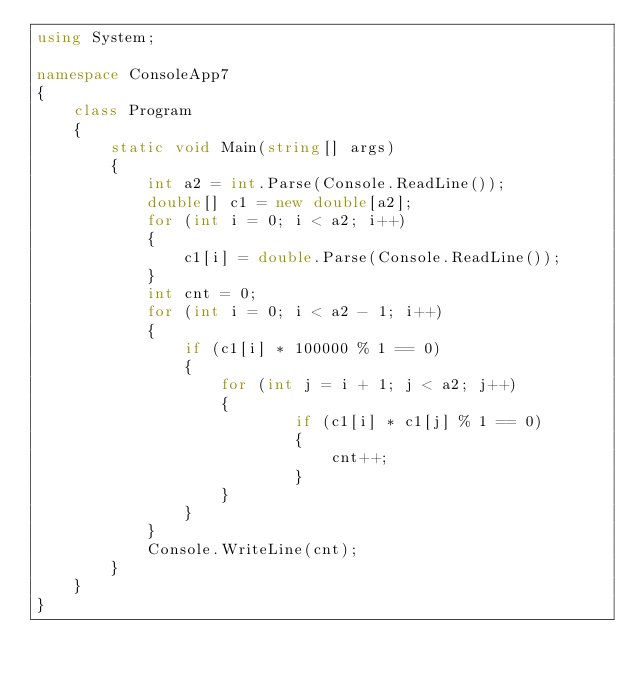Convert code to text. <code><loc_0><loc_0><loc_500><loc_500><_C#_>using System;

namespace ConsoleApp7
{
    class Program
    {
        static void Main(string[] args)
        {
            int a2 = int.Parse(Console.ReadLine());
            double[] c1 = new double[a2];
            for (int i = 0; i < a2; i++)
            {
                c1[i] = double.Parse(Console.ReadLine());
            }
            int cnt = 0;
            for (int i = 0; i < a2 - 1; i++)
            {
                if (c1[i] * 100000 % 1 == 0)
                {
                    for (int j = i + 1; j < a2; j++)
                    {
                            if (c1[i] * c1[j] % 1 == 0)
                            {
                                cnt++;
                            }
                    }
                }
            }
            Console.WriteLine(cnt);
        }
    }
}
</code> 